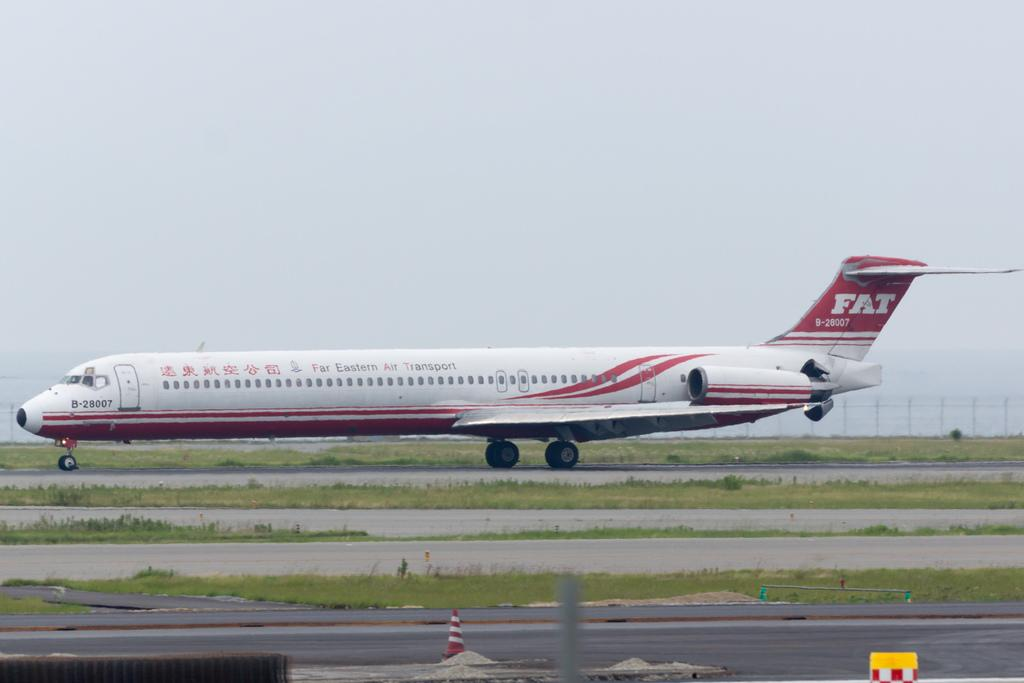<image>
Create a compact narrative representing the image presented. A Far Eastern Air Transport plane moves down the runway. 